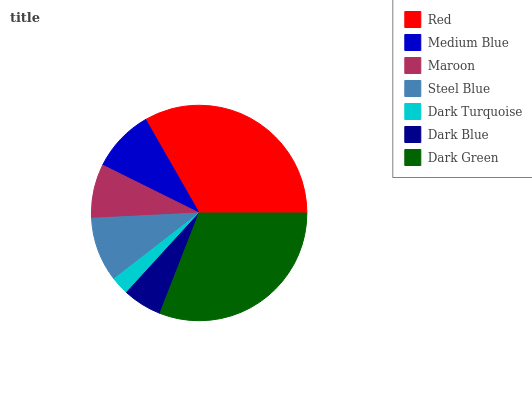Is Dark Turquoise the minimum?
Answer yes or no. Yes. Is Red the maximum?
Answer yes or no. Yes. Is Medium Blue the minimum?
Answer yes or no. No. Is Medium Blue the maximum?
Answer yes or no. No. Is Red greater than Medium Blue?
Answer yes or no. Yes. Is Medium Blue less than Red?
Answer yes or no. Yes. Is Medium Blue greater than Red?
Answer yes or no. No. Is Red less than Medium Blue?
Answer yes or no. No. Is Medium Blue the high median?
Answer yes or no. Yes. Is Medium Blue the low median?
Answer yes or no. Yes. Is Maroon the high median?
Answer yes or no. No. Is Maroon the low median?
Answer yes or no. No. 